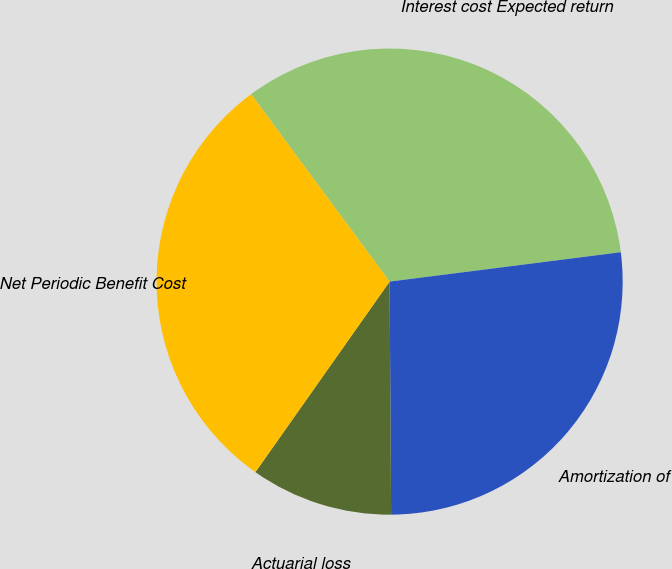<chart> <loc_0><loc_0><loc_500><loc_500><pie_chart><fcel>Interest cost Expected return<fcel>Amortization of<fcel>Actuarial loss<fcel>Net Periodic Benefit Cost<nl><fcel>33.12%<fcel>26.91%<fcel>9.87%<fcel>30.1%<nl></chart> 